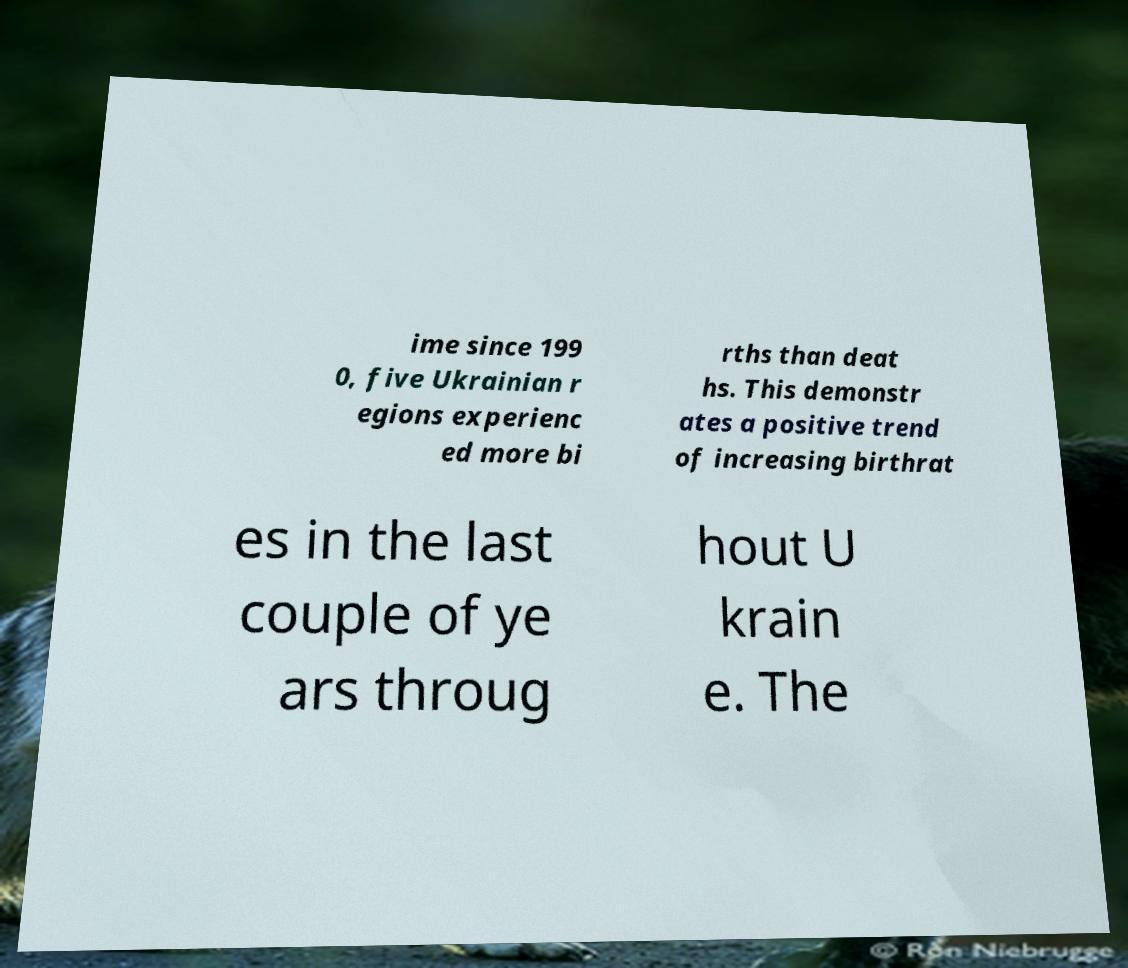I need the written content from this picture converted into text. Can you do that? ime since 199 0, five Ukrainian r egions experienc ed more bi rths than deat hs. This demonstr ates a positive trend of increasing birthrat es in the last couple of ye ars throug hout U krain e. The 